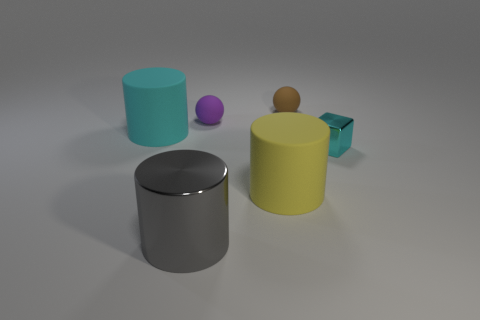Subtract all matte cylinders. How many cylinders are left? 1 Subtract all yellow cylinders. How many cylinders are left? 2 Subtract all cubes. How many objects are left? 5 Add 3 small purple objects. How many objects exist? 9 Add 6 large yellow rubber cylinders. How many large yellow rubber cylinders are left? 7 Add 5 yellow rubber cylinders. How many yellow rubber cylinders exist? 6 Subtract 0 red spheres. How many objects are left? 6 Subtract 1 cubes. How many cubes are left? 0 Subtract all red cylinders. Subtract all red blocks. How many cylinders are left? 3 Subtract all green cubes. How many blue cylinders are left? 0 